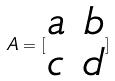<formula> <loc_0><loc_0><loc_500><loc_500>A = [ \begin{matrix} a & b \\ c & d \end{matrix} ]</formula> 